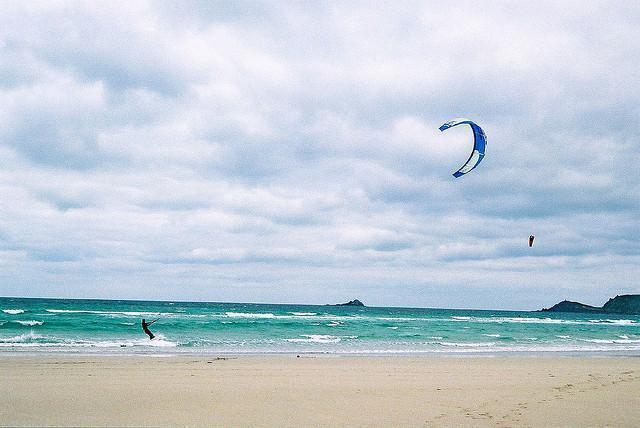What color are the eyes on the edges of the parasail pulling the skier?
Make your selection from the four choices given to correctly answer the question.
Options: Purple, red, pink, white. White. 